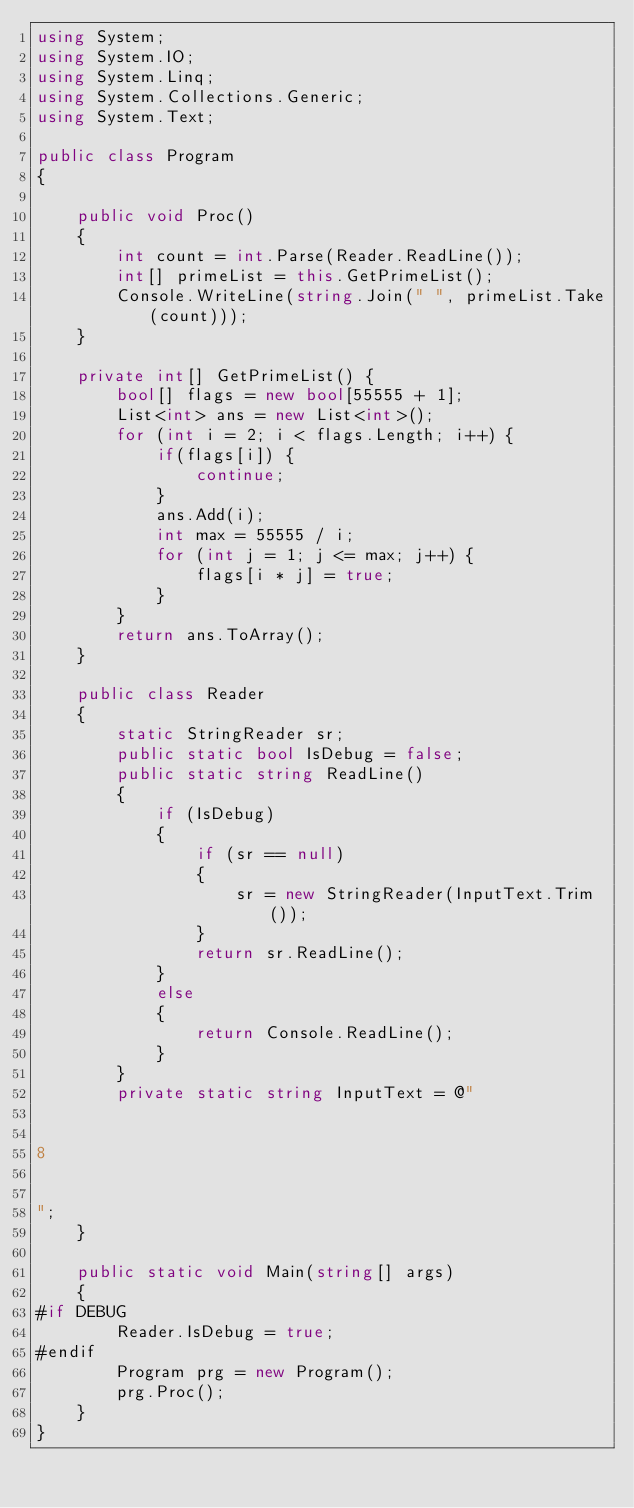Convert code to text. <code><loc_0><loc_0><loc_500><loc_500><_C#_>using System;
using System.IO;
using System.Linq;
using System.Collections.Generic;
using System.Text;

public class Program
{

    public void Proc()
    {
		int count = int.Parse(Reader.ReadLine());
		int[] primeList = this.GetPrimeList();
		Console.WriteLine(string.Join(" ", primeList.Take(count)));
	}

	private int[] GetPrimeList() {
		bool[] flags = new bool[55555 + 1];
		List<int> ans = new List<int>();
		for (int i = 2; i < flags.Length; i++) {
			if(flags[i]) {
				continue;
			}
			ans.Add(i);
			int max = 55555 / i;
			for (int j = 1; j <= max; j++) {
				flags[i * j] = true;
			}
		}
		return ans.ToArray();
	}

	public class Reader
    {
        static StringReader sr;
        public static bool IsDebug = false;
        public static string ReadLine()
        {
            if (IsDebug)
            {
                if (sr == null)
                {
                    sr = new StringReader(InputText.Trim());
                }
                return sr.ReadLine();
            }
            else
            {
                return Console.ReadLine();
            }
        }
        private static string InputText = @"


8


";
    }

    public static void Main(string[] args)
    {
#if DEBUG
        Reader.IsDebug = true;
#endif
        Program prg = new Program();
        prg.Proc();
    }
}</code> 